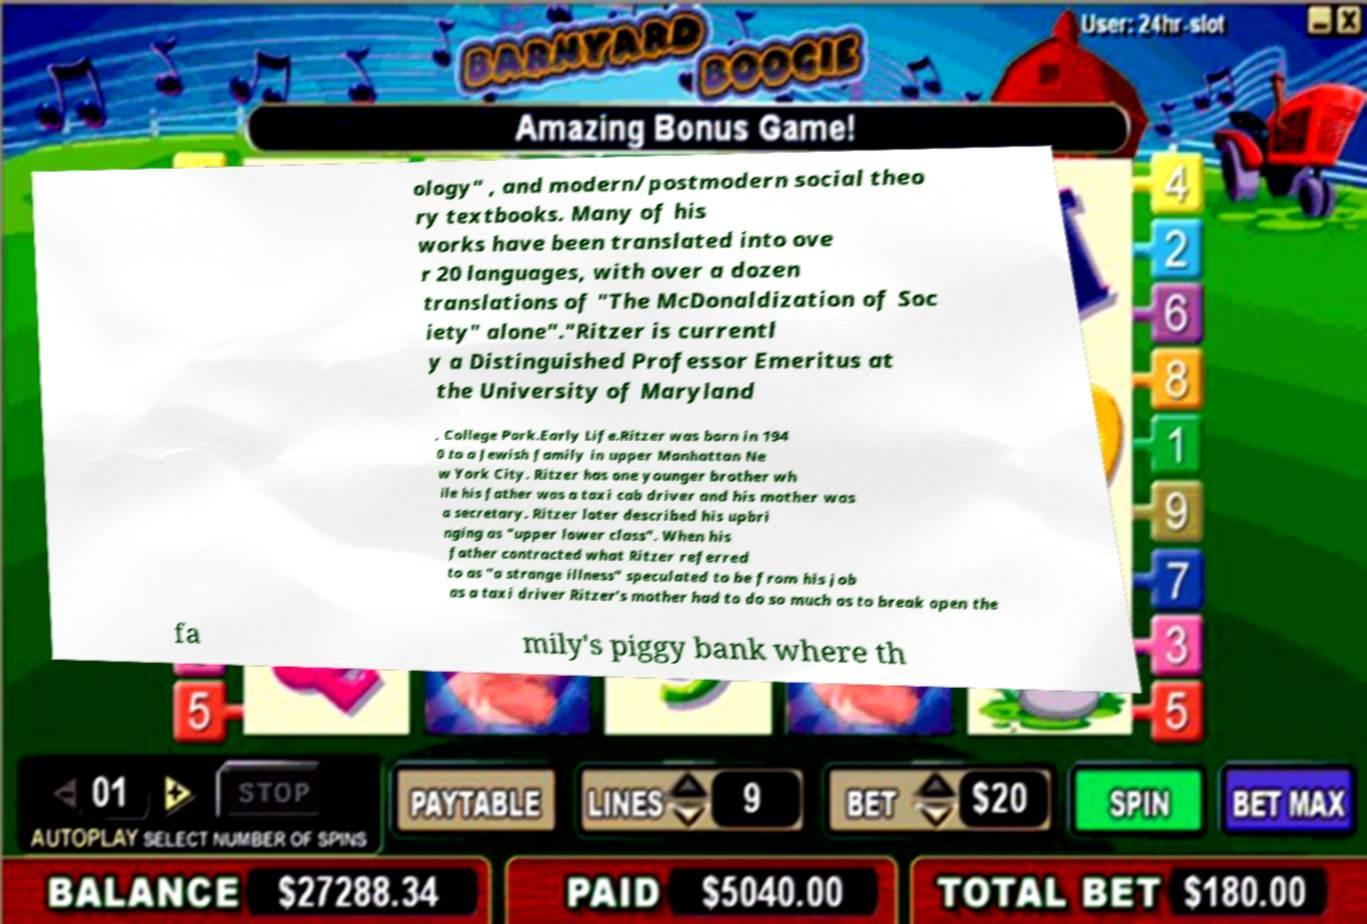What messages or text are displayed in this image? I need them in a readable, typed format. ology" , and modern/postmodern social theo ry textbooks. Many of his works have been translated into ove r 20 languages, with over a dozen translations of "The McDonaldization of Soc iety" alone"."Ritzer is currentl y a Distinguished Professor Emeritus at the University of Maryland , College Park.Early Life.Ritzer was born in 194 0 to a Jewish family in upper Manhattan Ne w York City. Ritzer has one younger brother wh ile his father was a taxi cab driver and his mother was a secretary. Ritzer later described his upbri nging as "upper lower class". When his father contracted what Ritzer referred to as "a strange illness" speculated to be from his job as a taxi driver Ritzer's mother had to do so much as to break open the fa mily's piggy bank where th 